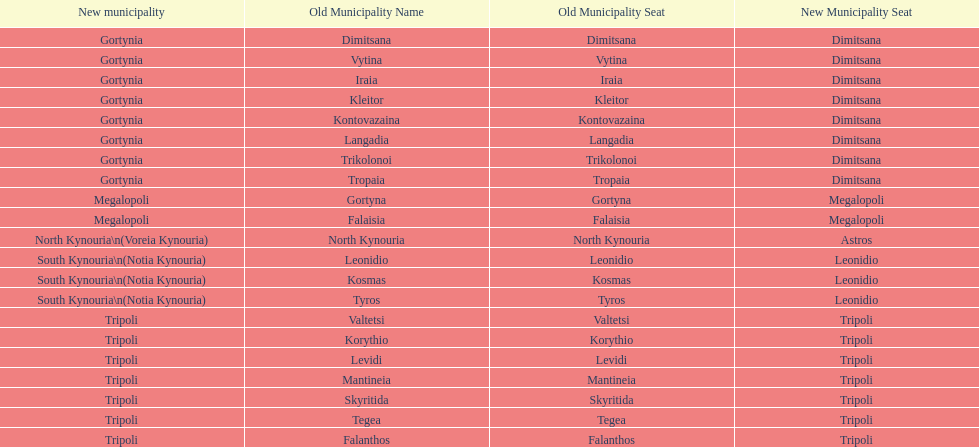What is the new municipality of tyros? South Kynouria. 